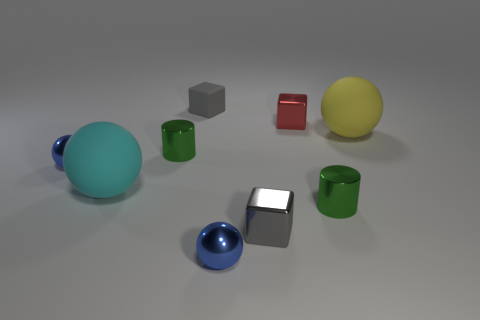Subtract all tiny metallic cubes. How many cubes are left? 1 Subtract all cylinders. How many objects are left? 7 Subtract all yellow blocks. How many blue spheres are left? 2 Add 3 small green things. How many small green things exist? 5 Subtract all red cubes. How many cubes are left? 2 Subtract 0 gray balls. How many objects are left? 9 Subtract 2 cylinders. How many cylinders are left? 0 Subtract all cyan spheres. Subtract all green cubes. How many spheres are left? 3 Subtract all tiny yellow rubber cubes. Subtract all rubber objects. How many objects are left? 6 Add 8 small red things. How many small red things are left? 9 